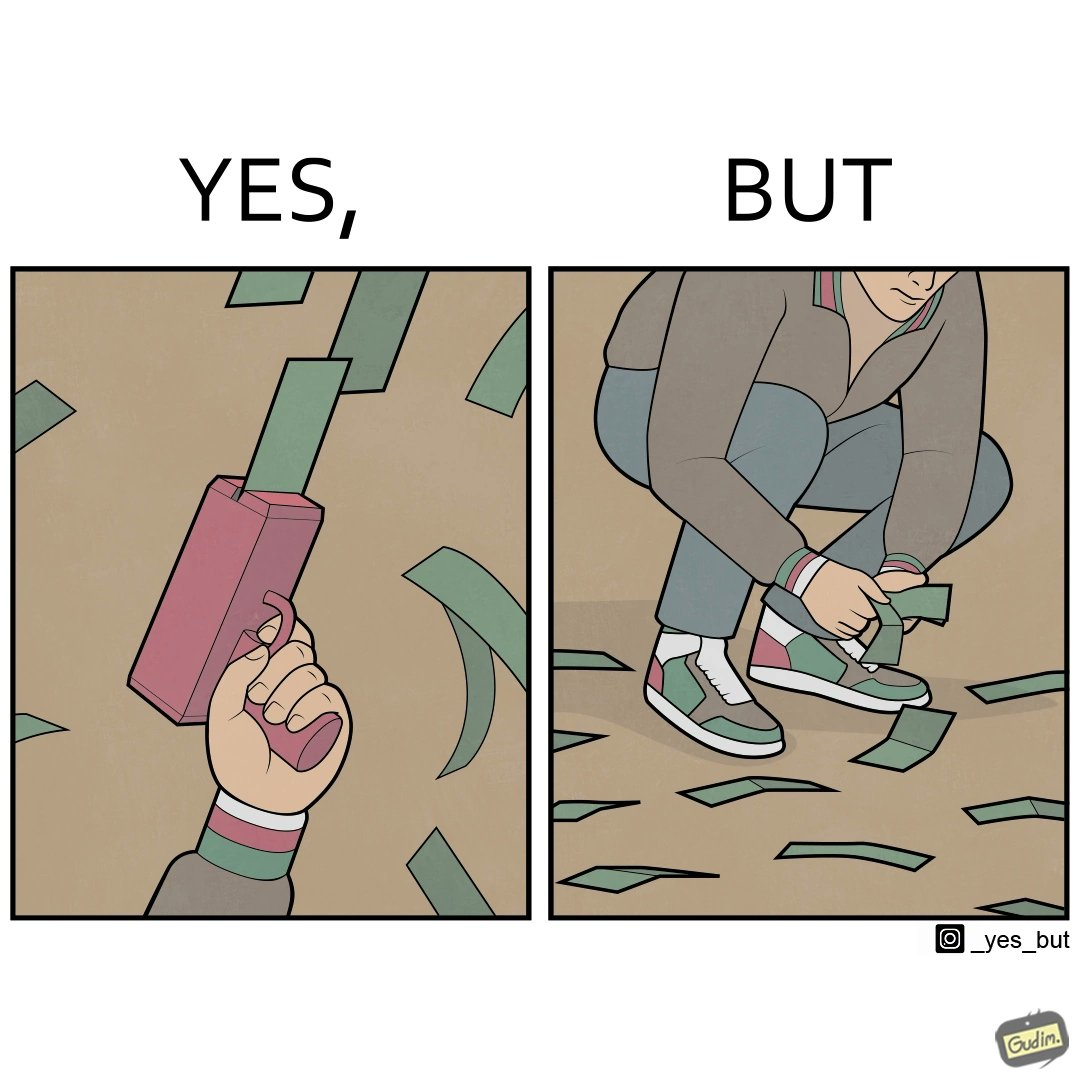What do you see in each half of this image? In the left part of the image: The image shows a hand holding a gun like object that is shooting out money bills in the air. The man's cuffs are green,red and white. In the right part of the image: The image showns a man crouching down to pick up fallen money bills on the ground. The man's cuffs are green, red and white. 